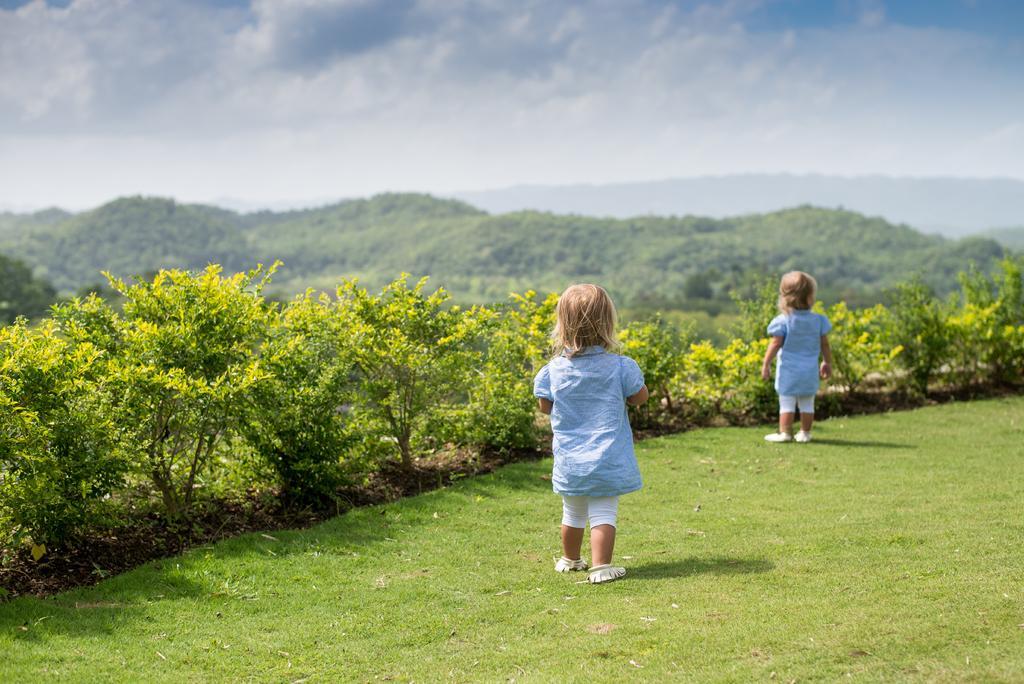Can you describe this image briefly? In this image we can see two kids on the ground, there are few plants, mountains and the sky with clouds in the background. 